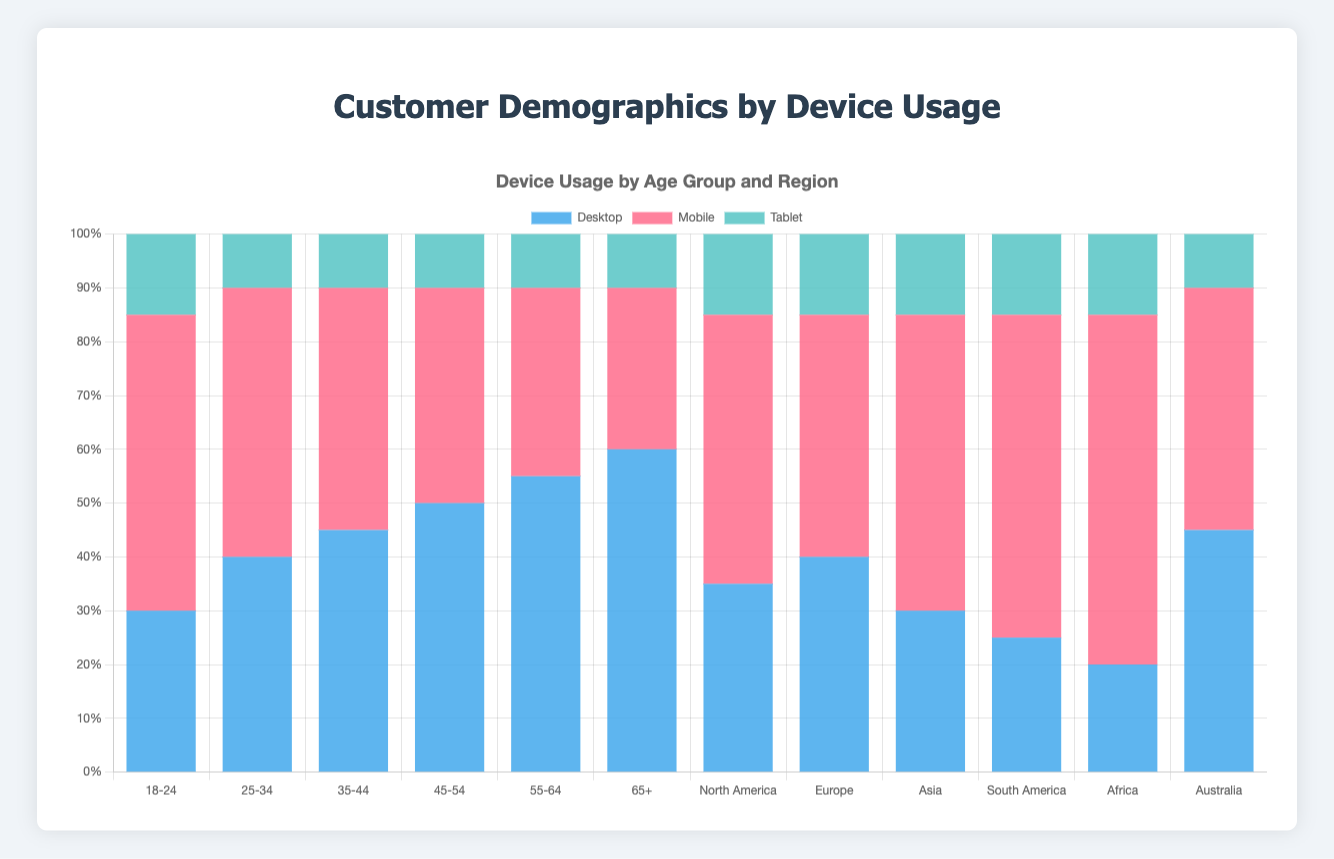What's the highest device usage for the 18-24 age group? Look at the bar for the 18-24 age group and identify the tallest segment. In this case, the tallest segment is for Mobile.
Answer: Mobile Which age group has the highest Desktop usage? Compare the heights of the Desktop segments across all age groups. The 65+ age group has the tallest Desktop segment.
Answer: 65+ In which region is Mobile usage the least? Compare the Mobile segments across all regions. Australia's Mobile usage segment is the smallest among the regions.
Answer: Australia What is the total device usage (Desktop + Mobile + Tablet) for the 35-44 age group? Sum the values of Desktop, Mobile, and Tablet for the 35-44 age group: 45 + 45 + 10 = 100.
Answer: 100 Is Mobile usage higher than Desktop usage in the 25-34 age group? Compare the heights of the Mobile and Desktop segments for the 25-34 age group. Mobile usage (50) is higher than Desktop usage (40).
Answer: Yes Which region has the lowest Desktop usage? Compare the heights of the Desktop segments across all regions. Africa has the smallest Desktop segment.
Answer: Africa In the 55-64 age group, how much more is Desktop usage compared to Mobile usage? Subtract the Mobile usage from the Desktop usage for the 55-64 age group: 55 - 35 = 20.
Answer: 20 Which device type has the smallest variation in usage across all age groups? Check the difference between the highest and lowest usage values for Desktop, Mobile, and Tablet across all age groups. Tablet usage varies the least, with a consistent value of either 10 or 15.
Answer: Tablet How does Mobile usage in Asia compare to Mobile usage in Africa? Compare the Mobile segments for Asia and Africa. Both have a Mobile usage of 55 and 65 respectively, making Mobile usage higher in Africa.
Answer: Africa In which age group is the Tablet usage the same across different regions? Tablet usage is the same when it consistently shows the same height, here, Tablet usage is 15 for North America, Europe, Asia, South America, and Africa.
Answer: North America, Europe, Asia, South America, and Africa 